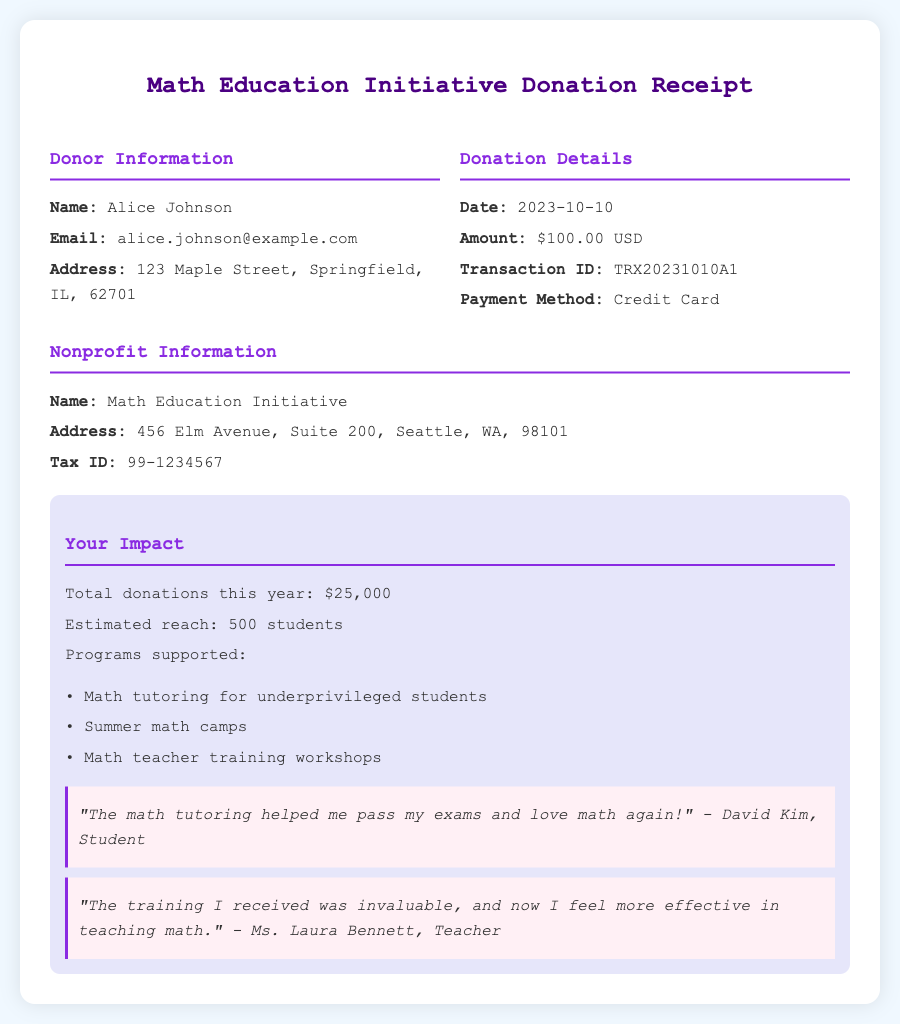What is the donor's name? The donor's name is found in the "Donor Information" section of the document.
Answer: Alice Johnson What is the donation amount? The donation amount is provided under "Donation Details" in the document.
Answer: $100.00 USD What is the transaction date? The transaction date is specified in the "Donation Details" section of the document.
Answer: 2023-10-10 What is the email of the donor? The donor's email is listed in the "Donor Information" section of the document.
Answer: alice.johnson@example.com What is the estimated reach of donations this year? The estimated reach is mentioned in the "Your Impact" section of the document.
Answer: 500 students What programs are supported by the donations? Programs supported are listed under "Your Impact" in the document.
Answer: Math tutoring for underprivileged students, Summer math camps, Math teacher training workshops How many total donations have been made this year? This information is found in the "Your Impact" section of the document.
Answer: $25,000 What is the nonprofit's tax ID? The nonprofit's tax ID is found in the "Nonprofit Information" section of the document.
Answer: 99-1234567 What payment method was used for the donation? The payment method is specified in the "Donation Details" section of the document.
Answer: Credit Card 